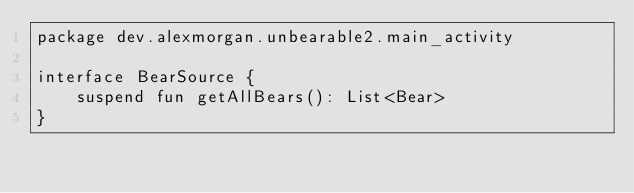Convert code to text. <code><loc_0><loc_0><loc_500><loc_500><_Kotlin_>package dev.alexmorgan.unbearable2.main_activity

interface BearSource {
    suspend fun getAllBears(): List<Bear>
}</code> 